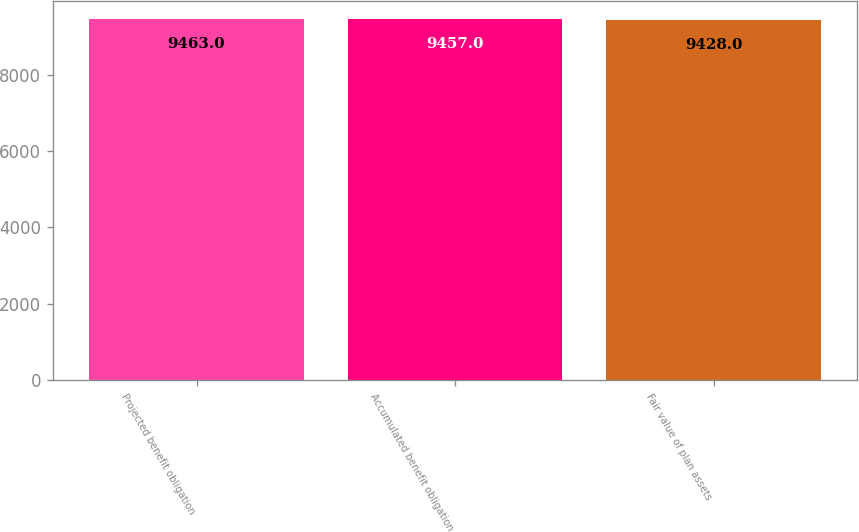Convert chart. <chart><loc_0><loc_0><loc_500><loc_500><bar_chart><fcel>Projected benefit obligation<fcel>Accumulated benefit obligation<fcel>Fair value of plan assets<nl><fcel>9463<fcel>9457<fcel>9428<nl></chart> 